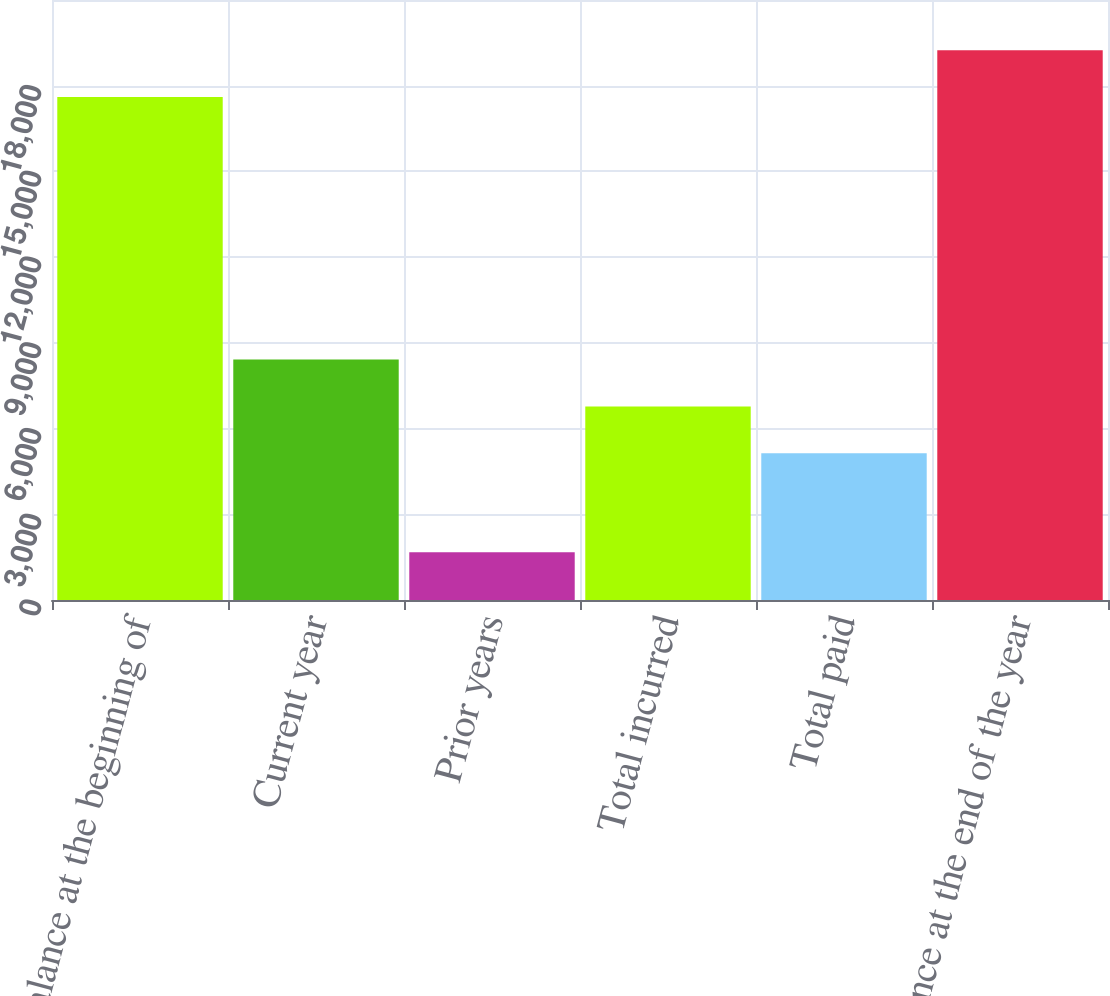<chart> <loc_0><loc_0><loc_500><loc_500><bar_chart><fcel>Balance at the beginning of<fcel>Current year<fcel>Prior years<fcel>Total incurred<fcel>Total paid<fcel>Balance at the end of the year<nl><fcel>17602<fcel>8415.4<fcel>1671<fcel>6774.7<fcel>5134<fcel>19242.7<nl></chart> 